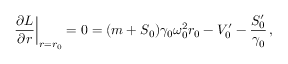<formula> <loc_0><loc_0><loc_500><loc_500>{ \frac { \partial L } { \partial r } } \right | _ { r = r _ { 0 } } = 0 = ( m + S _ { 0 } ) \gamma _ { 0 } \omega _ { 0 } ^ { 2 } r _ { 0 } - V _ { 0 } ^ { \prime } - { \frac { S _ { 0 } ^ { \prime } } { \gamma _ { 0 } } } \, ,</formula> 